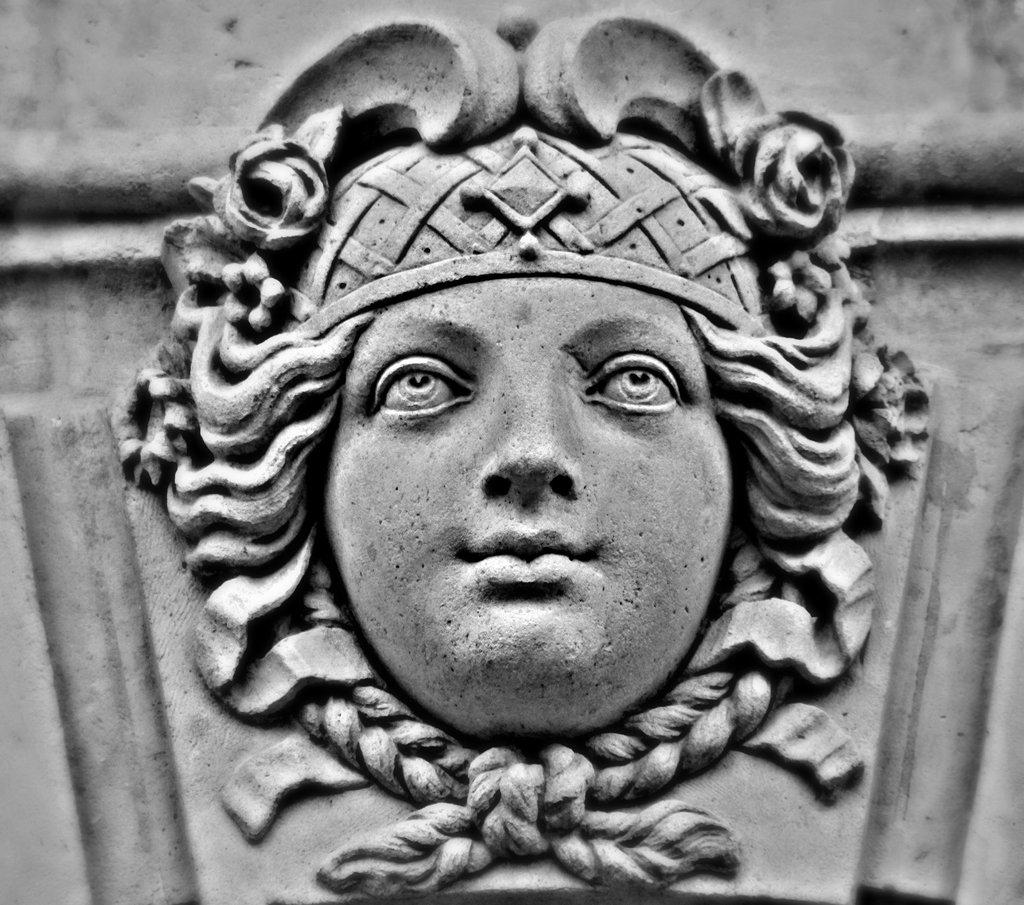What is the main subject of the picture? The main subject of the picture is a sculpture. What color scheme is used in the image? The image is in black and white color. What type of science is being demonstrated by the sculpture in the image? There is no indication of any scientific demonstration in the image; it simply features a sculpture in black and white. How does the sculpture capture the attention of the viewer in the image? The image does not show any viewers or their reactions, so it is impossible to determine how the sculpture captures their attention. 